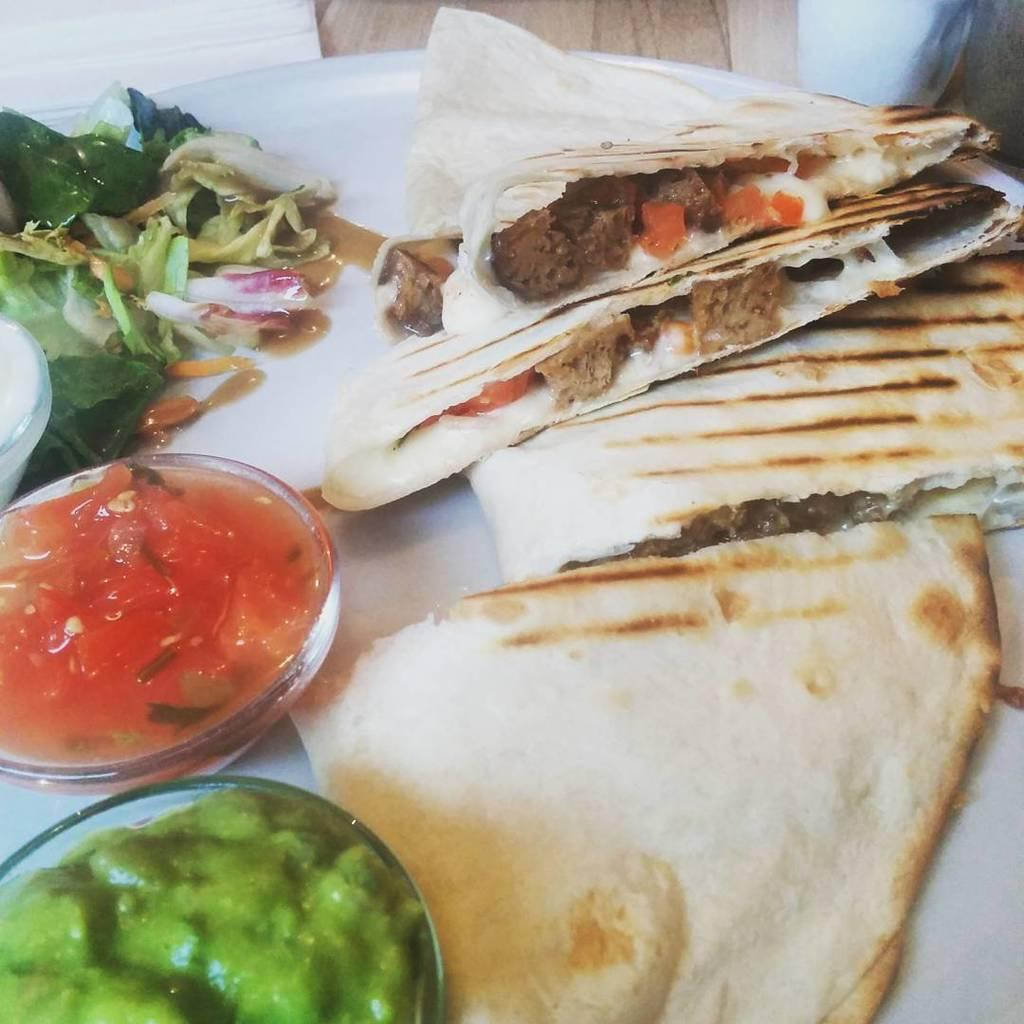What is on the plate in the image? There are food items on a plate in the image. Can you describe the type of food on the plate? There is a salad on the plate. What else is present on the plate or nearby that might be used with the food? There are sauces in cups in the image. How many tickets are visible in the image? There are no tickets present in the image. Can you describe the ear of the person in the image? There is no person present in the image, so it is not possible to describe their ear. 